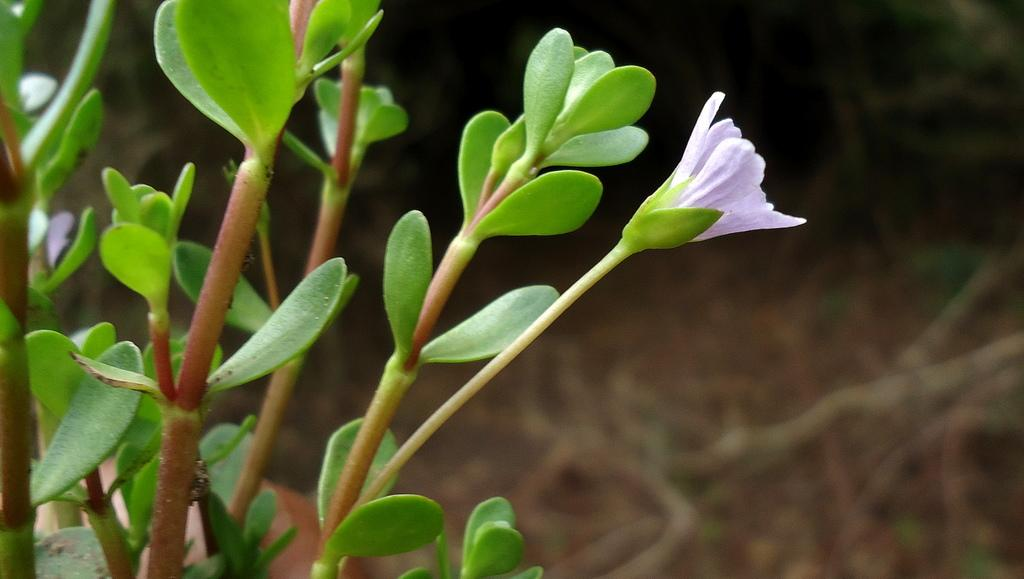What celestial bodies are depicted in the image? There are planets in the image. What type of plant is present in the image? There is a flower in the image. How would you describe the background of the image? The background of the image is blurred. What type of songs can be heard coming from the planets in the image? There are no sounds, including songs, present in the image, as it features planets and a flower with a blurred background. 